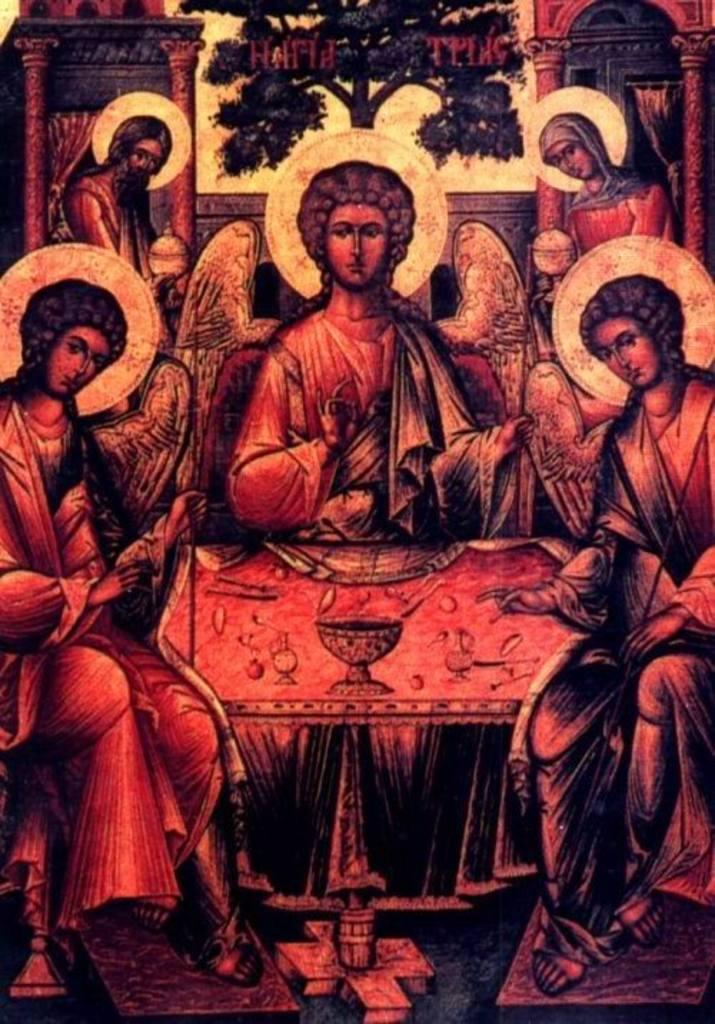What can be seen in the image? There are people and objects in the image. Can you describe any specific features in the background of the image? Yes, there are pillars and a tree in the background of the image. How many daughters are visible in the image? There is no mention of a daughter in the image. What type of cakes are being pushed in the image? There is no reference to cakes or pushing in the image. 